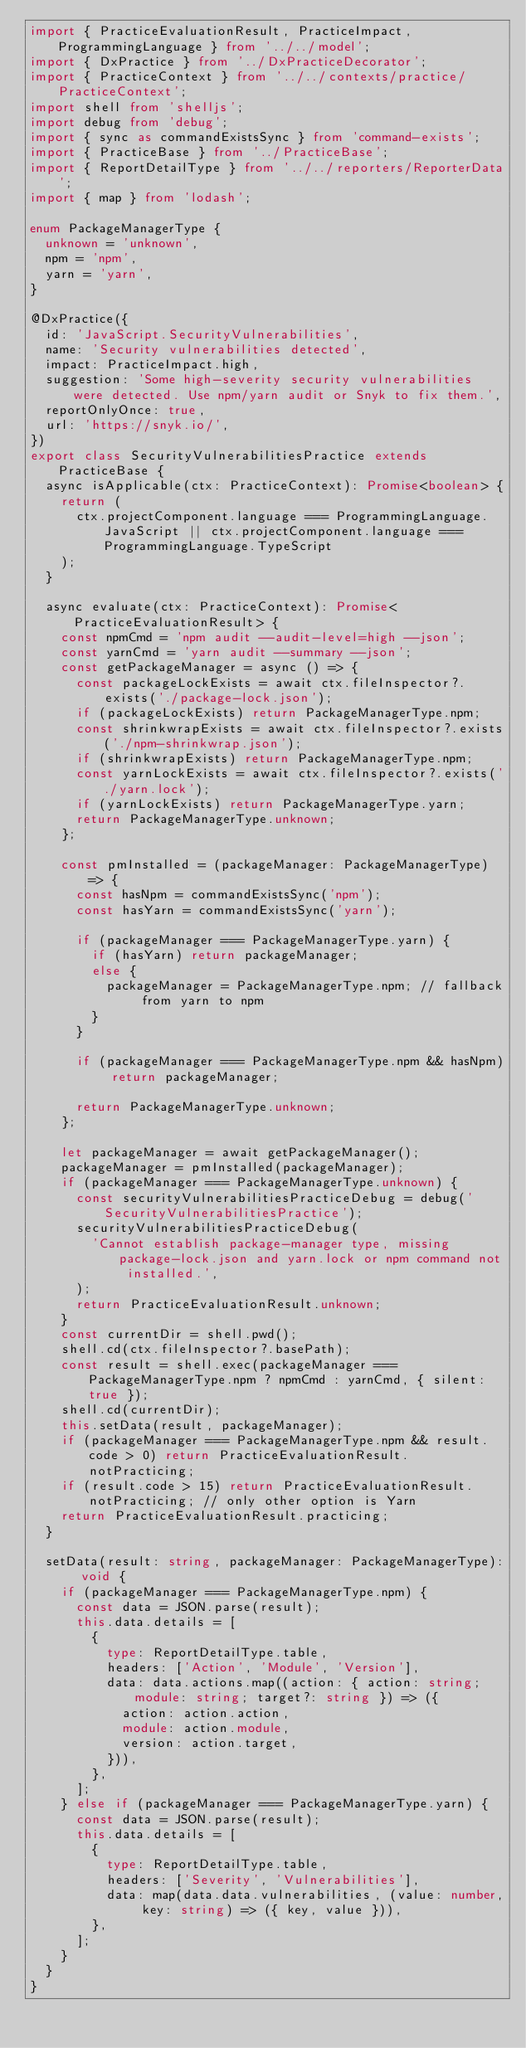<code> <loc_0><loc_0><loc_500><loc_500><_TypeScript_>import { PracticeEvaluationResult, PracticeImpact, ProgrammingLanguage } from '../../model';
import { DxPractice } from '../DxPracticeDecorator';
import { PracticeContext } from '../../contexts/practice/PracticeContext';
import shell from 'shelljs';
import debug from 'debug';
import { sync as commandExistsSync } from 'command-exists';
import { PracticeBase } from '../PracticeBase';
import { ReportDetailType } from '../../reporters/ReporterData';
import { map } from 'lodash';

enum PackageManagerType {
  unknown = 'unknown',
  npm = 'npm',
  yarn = 'yarn',
}

@DxPractice({
  id: 'JavaScript.SecurityVulnerabilities',
  name: 'Security vulnerabilities detected',
  impact: PracticeImpact.high,
  suggestion: 'Some high-severity security vulnerabilities were detected. Use npm/yarn audit or Snyk to fix them.',
  reportOnlyOnce: true,
  url: 'https://snyk.io/',
})
export class SecurityVulnerabilitiesPractice extends PracticeBase {
  async isApplicable(ctx: PracticeContext): Promise<boolean> {
    return (
      ctx.projectComponent.language === ProgrammingLanguage.JavaScript || ctx.projectComponent.language === ProgrammingLanguage.TypeScript
    );
  }

  async evaluate(ctx: PracticeContext): Promise<PracticeEvaluationResult> {
    const npmCmd = 'npm audit --audit-level=high --json';
    const yarnCmd = 'yarn audit --summary --json';
    const getPackageManager = async () => {
      const packageLockExists = await ctx.fileInspector?.exists('./package-lock.json');
      if (packageLockExists) return PackageManagerType.npm;
      const shrinkwrapExists = await ctx.fileInspector?.exists('./npm-shrinkwrap.json');
      if (shrinkwrapExists) return PackageManagerType.npm;
      const yarnLockExists = await ctx.fileInspector?.exists('./yarn.lock');
      if (yarnLockExists) return PackageManagerType.yarn;
      return PackageManagerType.unknown;
    };

    const pmInstalled = (packageManager: PackageManagerType) => {
      const hasNpm = commandExistsSync('npm');
      const hasYarn = commandExistsSync('yarn');

      if (packageManager === PackageManagerType.yarn) {
        if (hasYarn) return packageManager;
        else {
          packageManager = PackageManagerType.npm; // fallback from yarn to npm
        }
      }

      if (packageManager === PackageManagerType.npm && hasNpm) return packageManager;

      return PackageManagerType.unknown;
    };

    let packageManager = await getPackageManager();
    packageManager = pmInstalled(packageManager);
    if (packageManager === PackageManagerType.unknown) {
      const securityVulnerabilitiesPracticeDebug = debug('SecurityVulnerabilitiesPractice');
      securityVulnerabilitiesPracticeDebug(
        'Cannot establish package-manager type, missing package-lock.json and yarn.lock or npm command not installed.',
      );
      return PracticeEvaluationResult.unknown;
    }
    const currentDir = shell.pwd();
    shell.cd(ctx.fileInspector?.basePath);
    const result = shell.exec(packageManager === PackageManagerType.npm ? npmCmd : yarnCmd, { silent: true });
    shell.cd(currentDir);
    this.setData(result, packageManager);
    if (packageManager === PackageManagerType.npm && result.code > 0) return PracticeEvaluationResult.notPracticing;
    if (result.code > 15) return PracticeEvaluationResult.notPracticing; // only other option is Yarn
    return PracticeEvaluationResult.practicing;
  }

  setData(result: string, packageManager: PackageManagerType): void {
    if (packageManager === PackageManagerType.npm) {
      const data = JSON.parse(result);
      this.data.details = [
        {
          type: ReportDetailType.table,
          headers: ['Action', 'Module', 'Version'],
          data: data.actions.map((action: { action: string; module: string; target?: string }) => ({
            action: action.action,
            module: action.module,
            version: action.target,
          })),
        },
      ];
    } else if (packageManager === PackageManagerType.yarn) {
      const data = JSON.parse(result);
      this.data.details = [
        {
          type: ReportDetailType.table,
          headers: ['Severity', 'Vulnerabilities'],
          data: map(data.data.vulnerabilities, (value: number, key: string) => ({ key, value })),
        },
      ];
    }
  }
}
</code> 